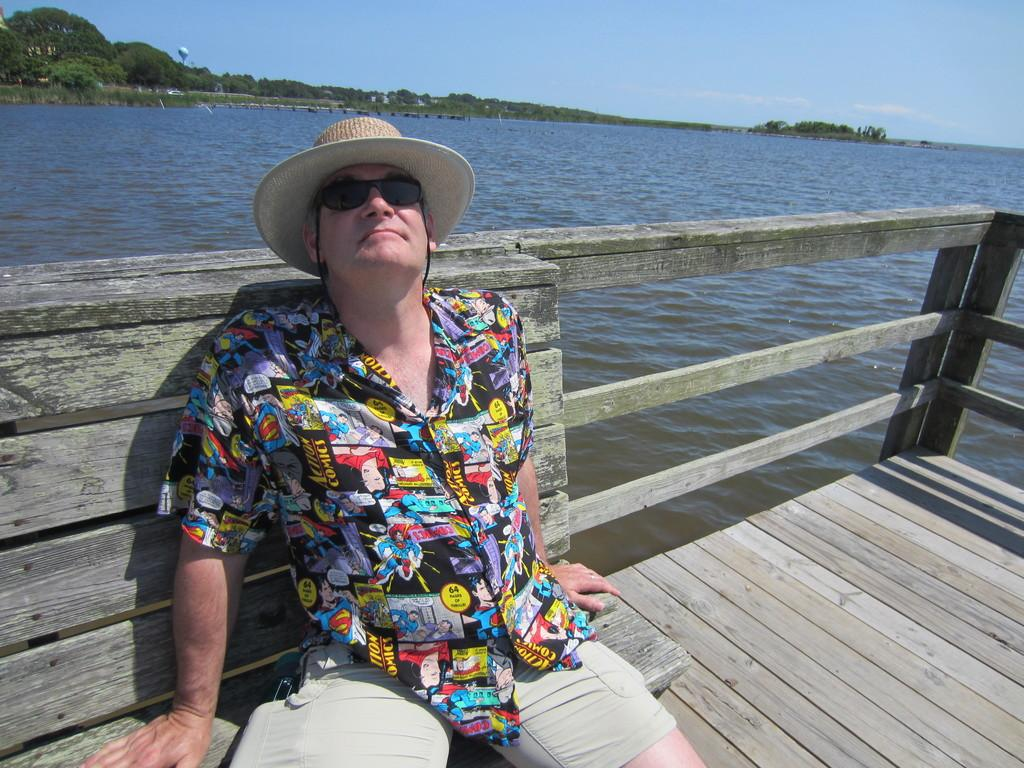What is the main subject of the image? There is a man in the image. What is the man wearing on his head? The man is wearing a hat. What is the man wearing to protect his eyes? The man is wearing goggles. Where is the man sitting in the image? The man is sitting on a bench. What type of flooring is present in the image? There is a wooden floor in the image. What architectural feature can be seen in the image? There are railings in the image. What can be seen in the background of the image? Water, trees, and the sky are visible in the background. How many worms can be seen crawling on the wooden floor in the image? There are no worms present in the image; it features a man sitting on a bench with a wooden floor. What type of milk is being served in the room in the image? There is no room or milk present in the image; it features a man sitting on a bench with a wooden floor, railings, and a background of water, trees, and the sky. 